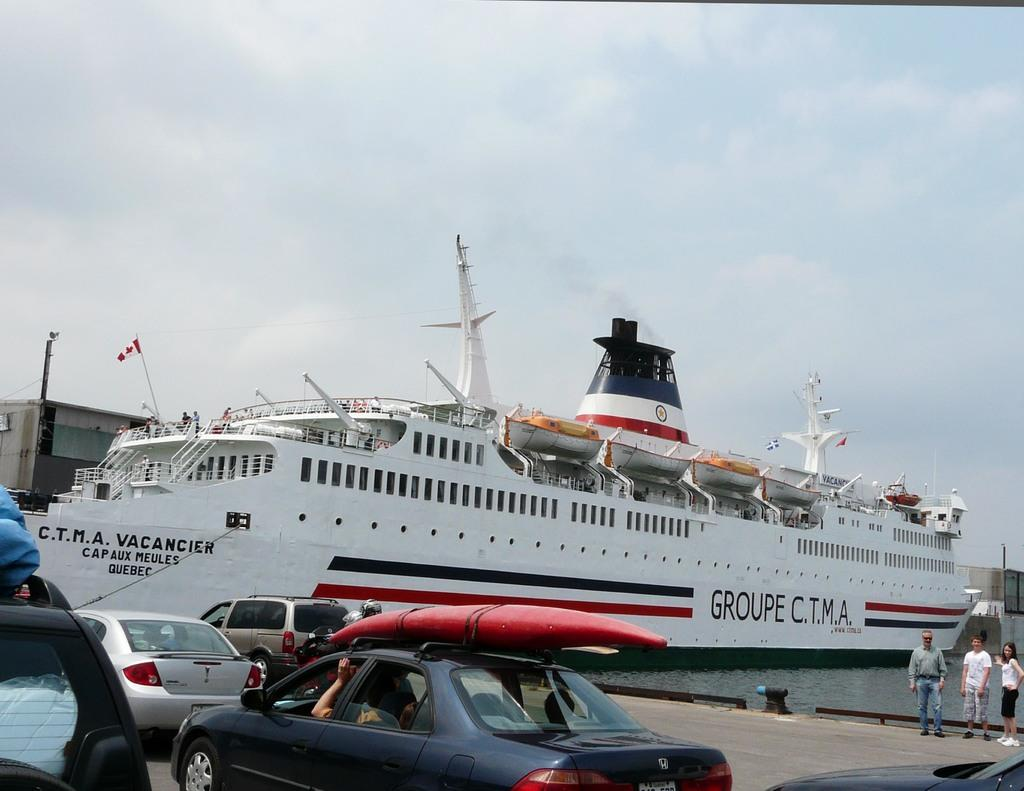What is happening on the left side of the image? There are cars moving on the road on the left side of the image. What can be seen in the middle of the image? There is a big ship in white color in the middle of the image. How many people are standing on the right side of the image? There are three persons standing on the right side of the image. What is visible at the top of the image? The sky is visible at the top of the image. What type of button is being pushed by the ship in the image? There is no button present in the image, and the ship is not shown pushing any buttons. How does the ship fall from the sky in the image? The ship is not falling from the sky in the image; it is stationary in the water. 